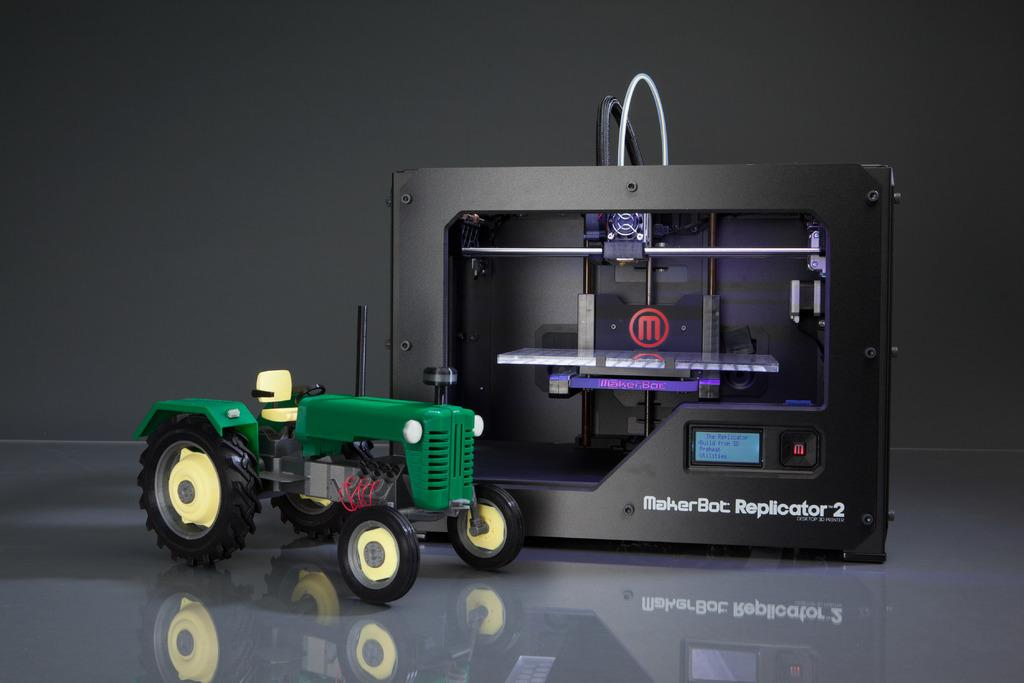What is the main object in the image? There is a machine in the image. What other object can be seen in the image? There is a toy vehicle in the image. What colors are present on the toy vehicle? The toy vehicle is green, black, and yellow in color. What is the color of the background in the image? The background of the image is black. What type of oatmeal is being served in the image? There is no oatmeal present in the image. Can you tell me how many pipes are connected to the machine in the image? The image does not show any pipes connected to the machine, so it is not possible to answer that question. 